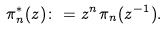<formula> <loc_0><loc_0><loc_500><loc_500>\pi _ { n } ^ { * } ( z ) \colon = z ^ { n } \pi _ { n } ( z ^ { - 1 } ) .</formula> 